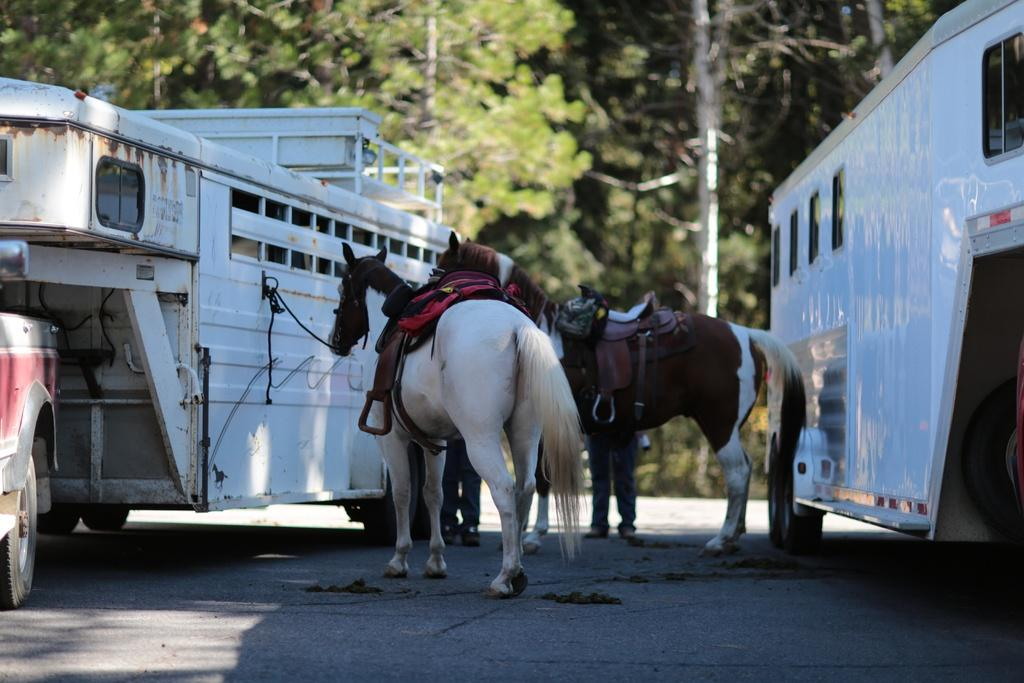What animals are present in the image? There are horses in the image. What else can be seen in the image besides the horses? There are vehicles in the image. What is at the bottom of the image? There is a road at the bottom of the image. What type of vegetation is visible in the background of the image? There are trees in the background of the image. What type of afterthought is being used to transport the crate in the image? There is no crate or afterthought present in the image. What type of plant is being used to water the horses in the image? There is no plant or watering activity involving the horses in the image. 